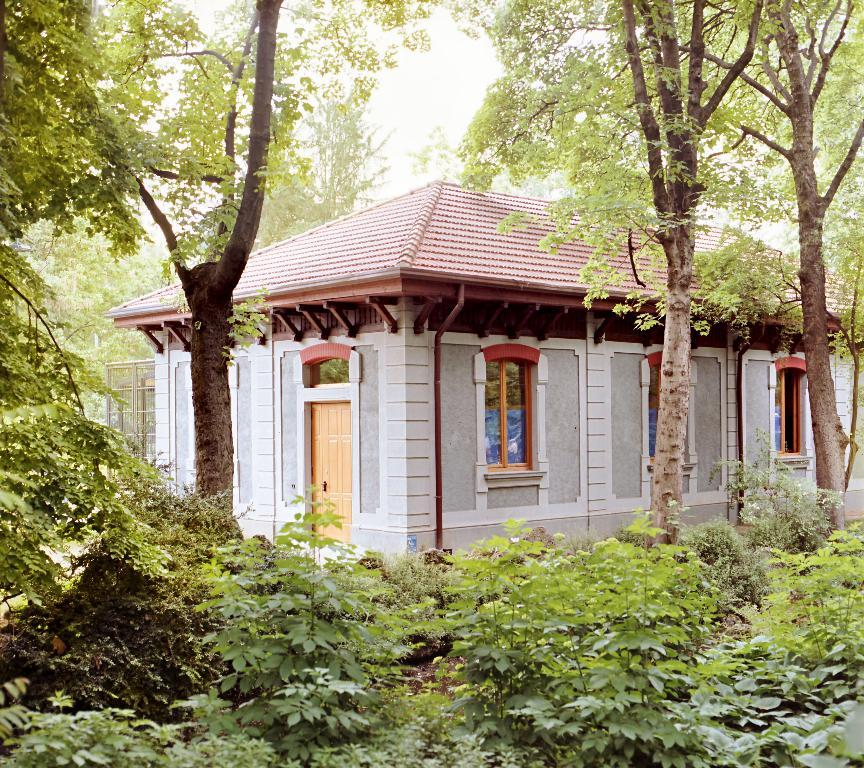What type of living organisms can be seen in the image? Plants can be seen in the image. What type of structure is present in the image? There is a house in the image. What can be seen in the background of the image? Trees are present in the background of the image. How many kittens are playing in the basin in the image? There are no kittens or basin present in the image. What type of hand is visible holding the plants in the image? There is no hand visible holding the plants in the image; the plants are not being held. 